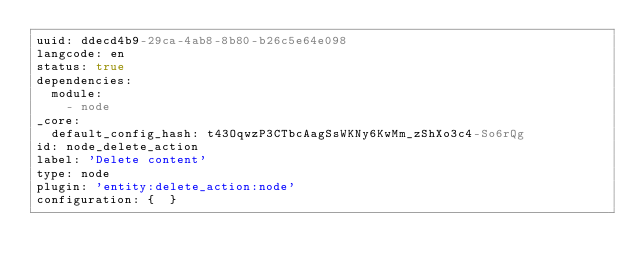Convert code to text. <code><loc_0><loc_0><loc_500><loc_500><_YAML_>uuid: ddecd4b9-29ca-4ab8-8b80-b26c5e64e098
langcode: en
status: true
dependencies:
  module:
    - node
_core:
  default_config_hash: t43OqwzP3CTbcAagSsWKNy6KwMm_zShXo3c4-So6rQg
id: node_delete_action
label: 'Delete content'
type: node
plugin: 'entity:delete_action:node'
configuration: {  }
</code> 